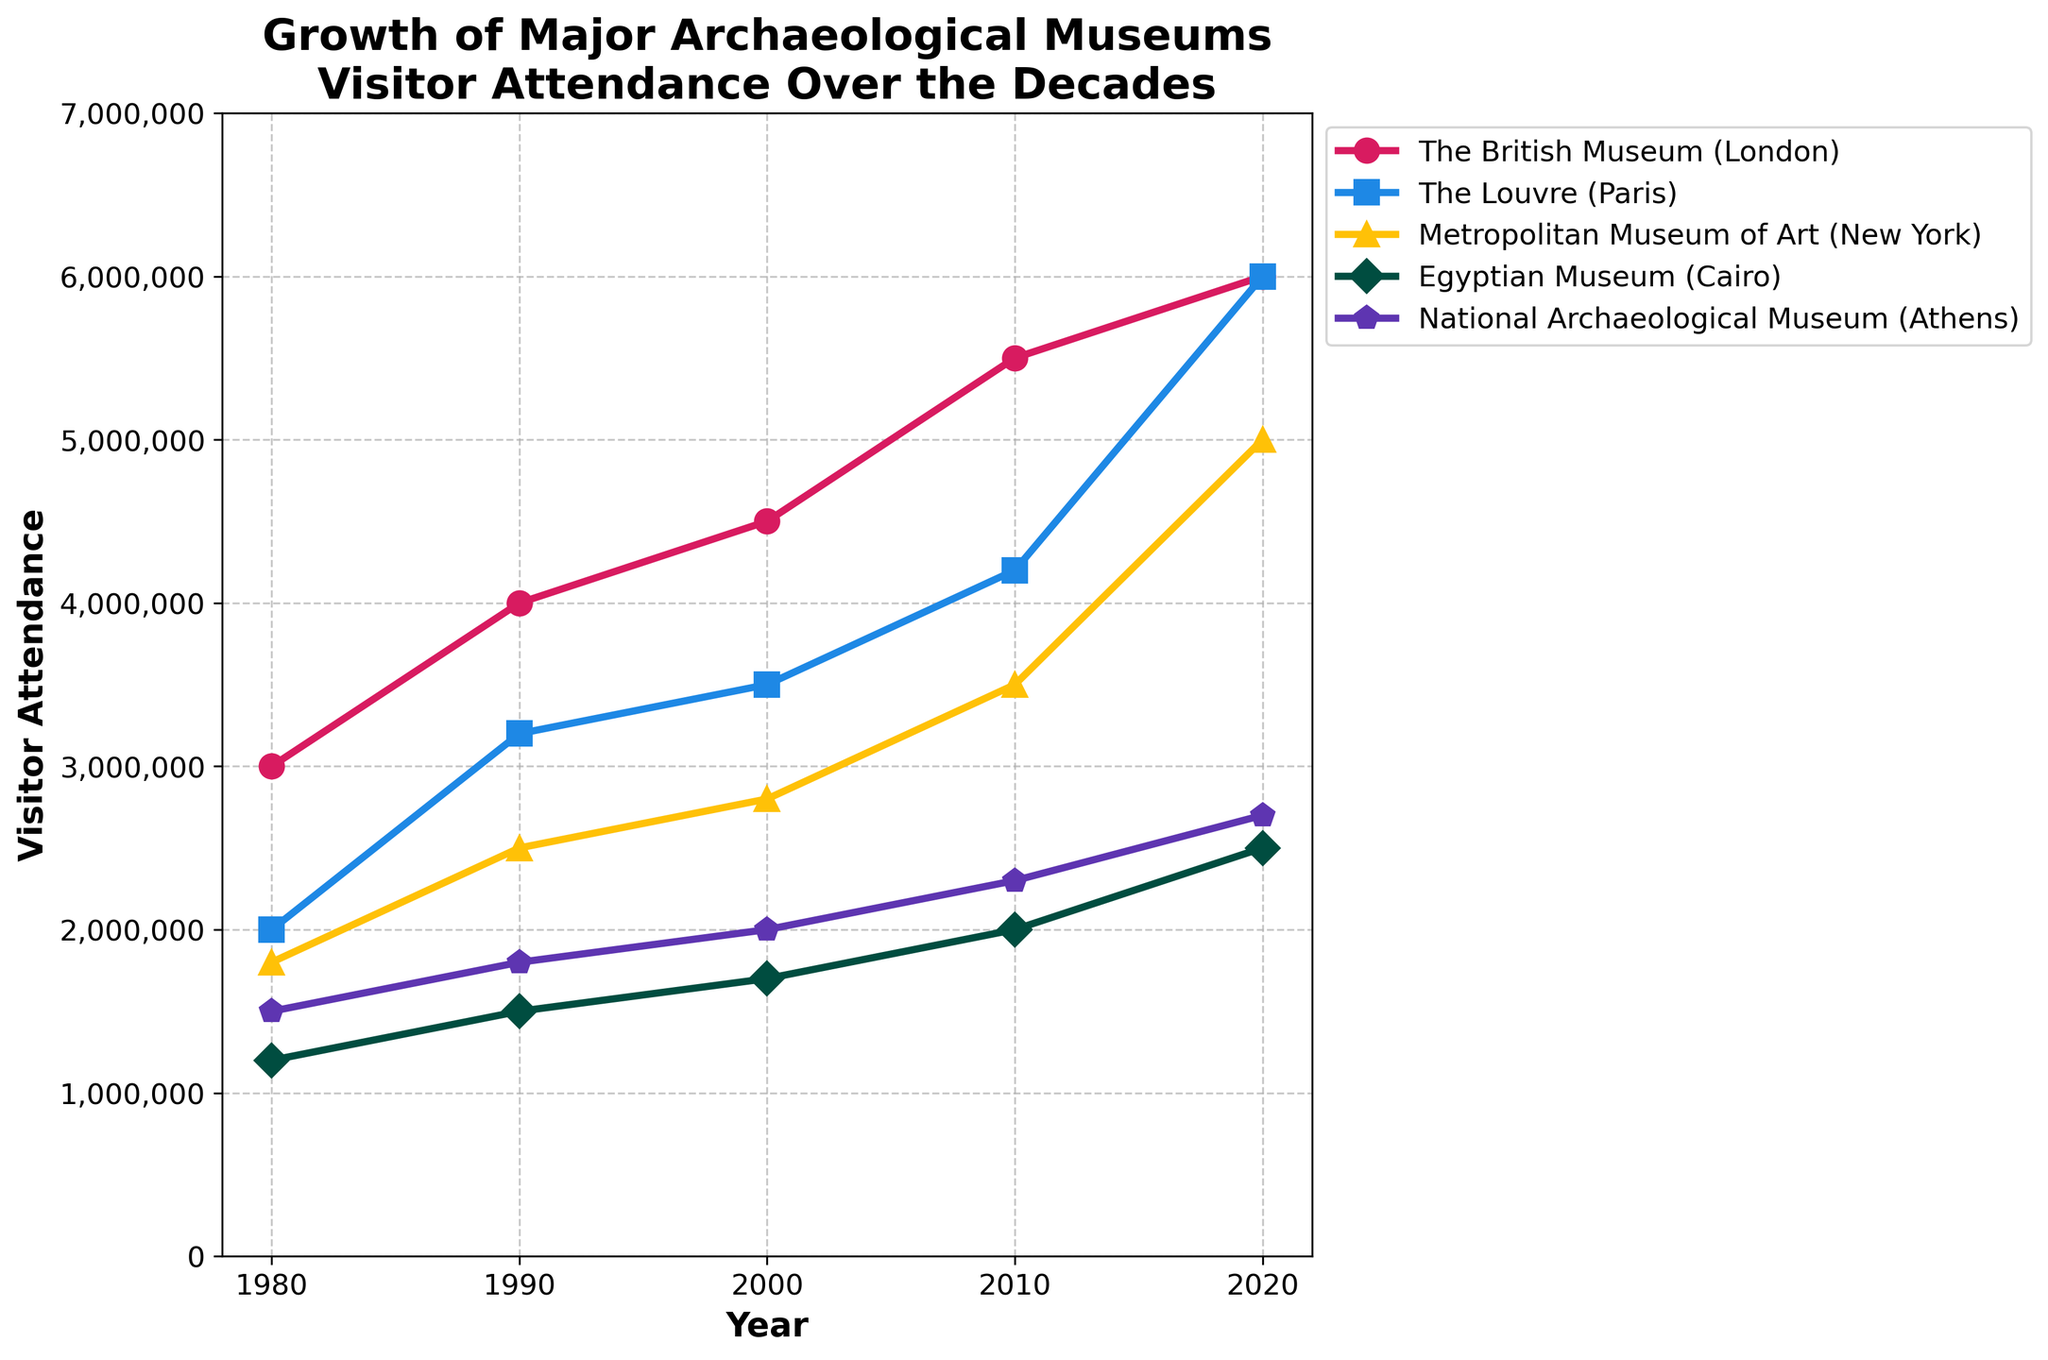What's the title of the figure? The title is often positioned at the top of a chart and provides an overview of what the figure represents. The title here would direct attention to the growth and visitor attendance of major archaeological museums across different years.
Answer: Growth of Major Archaeological Museums Visitor Attendance Over the Decades How many museums are represented in this figure? To determine the number of museums shown, you need to count the number of different lines or labels present in the legend. Each museum has a distinct line style, color, and marker.
Answer: 5 Which museum had the highest visitor attendance in 2020? Look at the data points corresponding to the year 2020 for each museum. Identify which point is positioned highest on the y-axis. The highest point represents the museum with the most visitors.
Answer: The British Museum (London) and The Louvre (Paris) What is the total visitor attendance for all museums combined in 1990? Identify the visitor attendance of each museum in 1990 from the data points. Sum these values to get the total. The values are 4000000 (British Museum) + 3200000 (Louvre) + 2500000 (Met) + 1500000 (Egyptian Museum) + 1800000 (National Archaeological Museum).
Answer: 1,300,000 Which museum observed the largest absolute increase in visitor attendance from 1980 to 2020? Calculate the difference in visitor attendance between 1980 and 2020 for each museum. Identify which difference is the largest. For the British Museum: 6000000 - 3000000 = 3000000, for The Louvre: 6000000 - 2000000 = 4000000, for the Metropolitan Museum of Art: 5000000 - 1800000 = 3200000, for the Egyptian Museum: 2500000 - 1200000 = 1300000, for the National Archaeological Museum: 2700000 - 1500000 = 1200000.
Answer: The Louvre (Paris) Between which two consecutive decades did the Metropolitan Museum of Art experience the greatest growth in visitor numbers? Calculate the growth in visitor numbers for each consecutive decade by finding the difference between the subsequent data points for the Metropolitan Museum of Art. Compare these differences to identify the greatest growth.
Answer: Between 2010 and 2020 Which two museums had an equal number of visitors in 2020? Inspect the y-axis values for the year 2020. Identify which two museums have the same y-axis value in that year.
Answer: The British Museum (London) and The Louvre (Paris) Which museum had the least increase in visitor attendance from 1980 to 2020? Calculate the increase in visitor attendance from 1980 to 2020 for each museum. Compare these increases to determine the smallest one. For the British Museum: 6000000 - 3000000 = 3000000, for The Louvre: 6000000 - 2000000 = 4000000, for the Metropolitan Museum of Art: 5000000 - 1800000 = 3200000, for the Egyptian Museum: 2500000 - 1200000 = 1300000, for the National Archaeological Museum: 2700000 - 1500000 = 1200000.
Answer: National Archaeological Museum (Athens) What is the average visitor attendance for the Egyptian Museum across all the decades presented? Find the visitor attendance for the Egyptian Museum in each specified year. Sum these values and then divide by the number of years (five). The values are 1200000, 1500000, 1700000, 2000000, 2500000. The sum is 1200000 + 1500000 + 1700000 + 2000000 + 2500000 = 8900000. Divide 8900000 by 5 for the average.
Answer: 1,780,000 